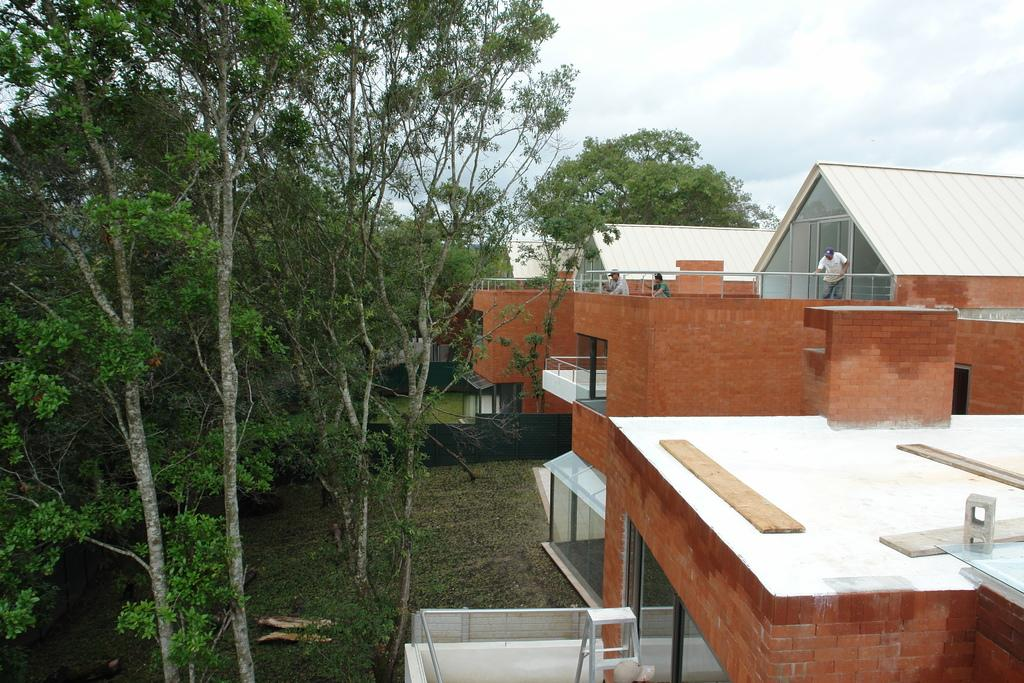What are the people in the image doing? The people in the image are working on top of a house. Can you describe the surrounding area in the image? There is another house beside the house they are working on, and there are trees in front of the house they are working on. How many frogs can be seen on the roof of the house they are working on? There are no frogs visible on the roof of the house they are working on in the image. What type of beam is being used to support the roof of the house they are working on? There is no information about the type of beam used to support the roof in the image. 